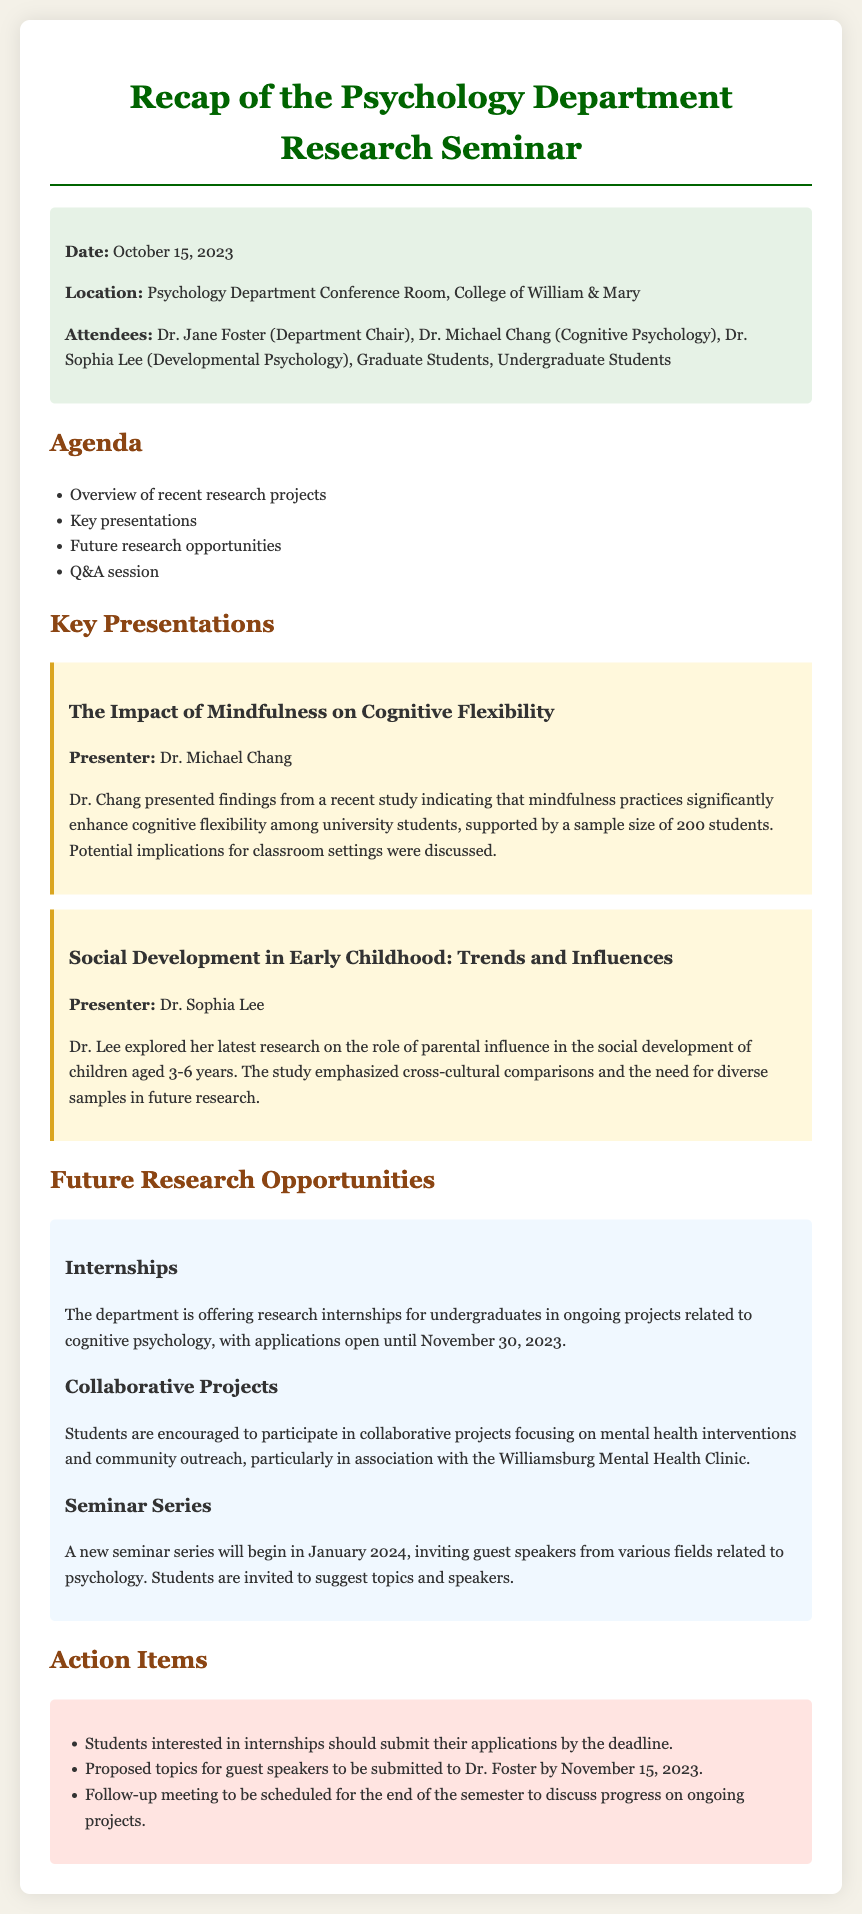What is the date of the seminar? The date of the seminar is stated in the meta-info section of the document.
Answer: October 15, 2023 Who presented on "The Impact of Mindfulness on Cognitive Flexibility"? This information is found under the key presentations section, specifically naming the presenter for this topic.
Answer: Dr. Michael Chang What type of research opportunities are offered for undergraduates? The document specifies the nature of the opportunities available to undergraduates in the future research opportunities section.
Answer: Research internships When is the application deadline for internships? The application deadline is mentioned in the section describing future research opportunities.
Answer: November 30, 2023 What will begin in January 2024? This question relates to the upcoming events mentioned in the future research opportunities section of the document.
Answer: A new seminar series What should students submit by November 15, 2023? This query focuses on action items from the document, which outline specific tasks and deadlines.
Answer: Proposed topics for guest speakers How many attendees were listed for the seminar? The number of attendees is mentioned in the meta-info section of the document outlining who was present.
Answer: Several (Doctoral, Graduate, and Undergraduate Students) 